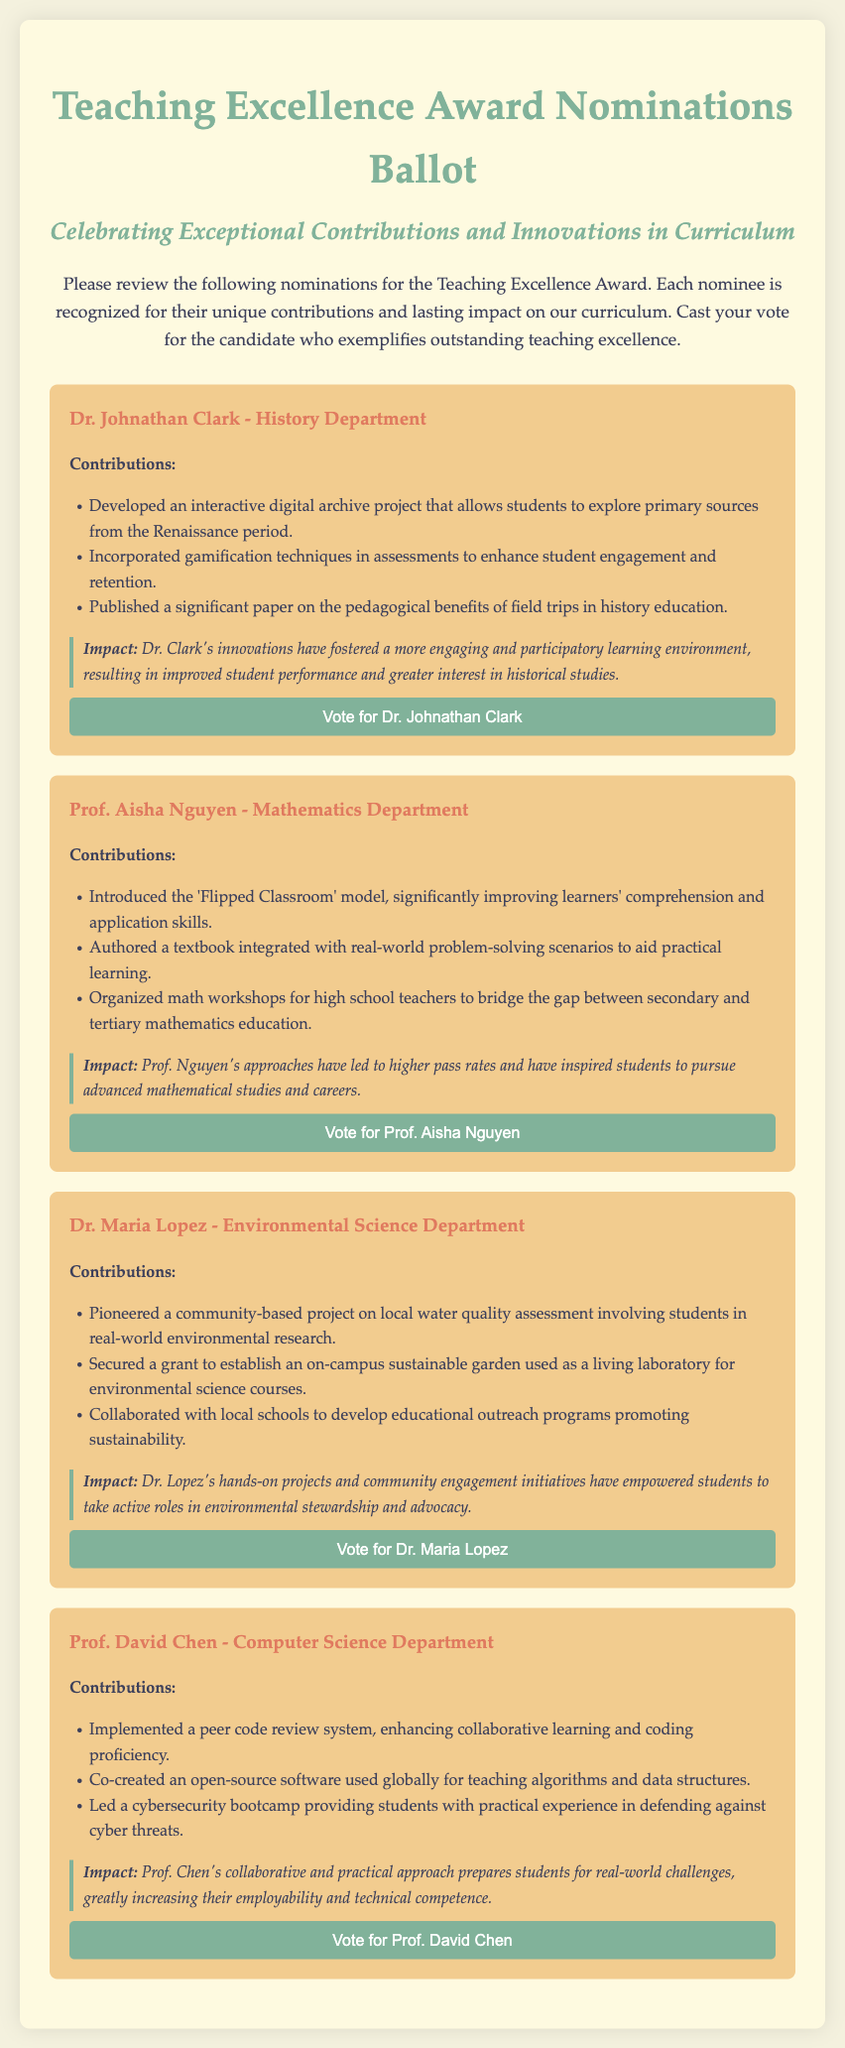What is the name of the award? The document discusses the "Teaching Excellence Award."
Answer: Teaching Excellence Award Who is the nominee from the History Department? The nominee for the History Department is Dr. Johnathan Clark.
Answer: Dr. Johnathan Clark What teaching model did Prof. Aisha Nguyen introduce? Prof. Aisha Nguyen introduced the 'Flipped Classroom' model.
Answer: Flipped Classroom Which department is Dr. Maria Lopez associated with? Dr. Maria Lopez is associated with the Environmental Science Department.
Answer: Environmental Science Department What specific contribution is Dr. Johnathan Clark known for? Dr. Johnathan Clark is known for developing an interactive digital archive project.
Answer: Interactive digital archive project How did Prof. Nguyen's approaches impact student pass rates? Prof. Nguyen's approaches led to higher pass rates.
Answer: Higher pass rates What community initiative did Dr. Lopez pioneer? Dr. Lopez pioneered a community-based project on local water quality assessment.
Answer: Local water quality assessment What practical experience did Prof. Chen provide? Prof. Chen led a cybersecurity bootcamp.
Answer: Cybersecurity bootcamp What type of educational outreach did Dr. Lopez collaborate on? Dr. Lopez collaborated on educational outreach programs promoting sustainability.
Answer: Sustainability 